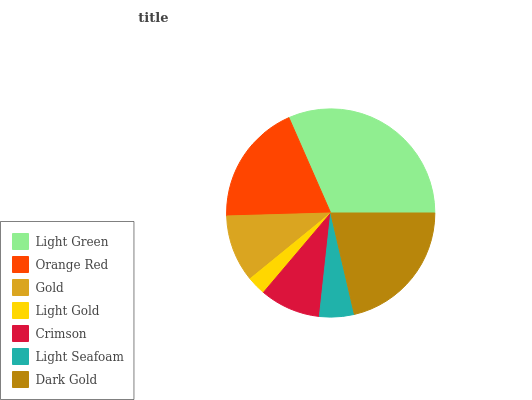Is Light Gold the minimum?
Answer yes or no. Yes. Is Light Green the maximum?
Answer yes or no. Yes. Is Orange Red the minimum?
Answer yes or no. No. Is Orange Red the maximum?
Answer yes or no. No. Is Light Green greater than Orange Red?
Answer yes or no. Yes. Is Orange Red less than Light Green?
Answer yes or no. Yes. Is Orange Red greater than Light Green?
Answer yes or no. No. Is Light Green less than Orange Red?
Answer yes or no. No. Is Gold the high median?
Answer yes or no. Yes. Is Gold the low median?
Answer yes or no. Yes. Is Light Gold the high median?
Answer yes or no. No. Is Crimson the low median?
Answer yes or no. No. 